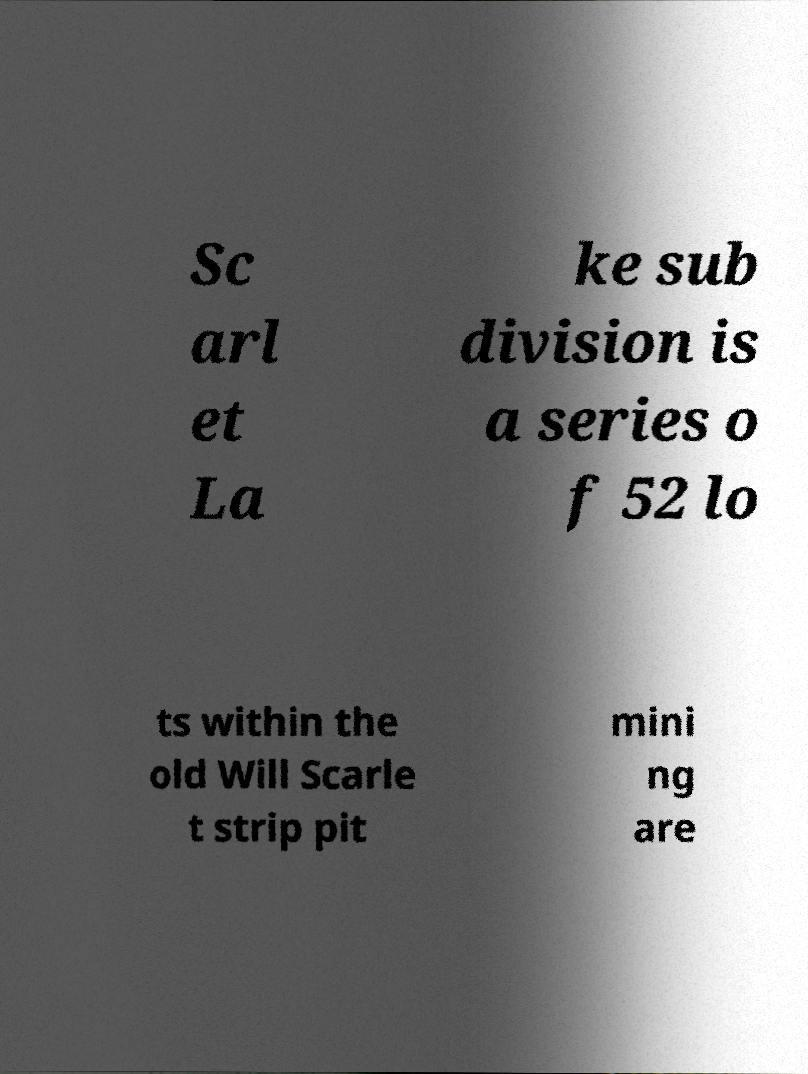Can you accurately transcribe the text from the provided image for me? Sc arl et La ke sub division is a series o f 52 lo ts within the old Will Scarle t strip pit mini ng are 